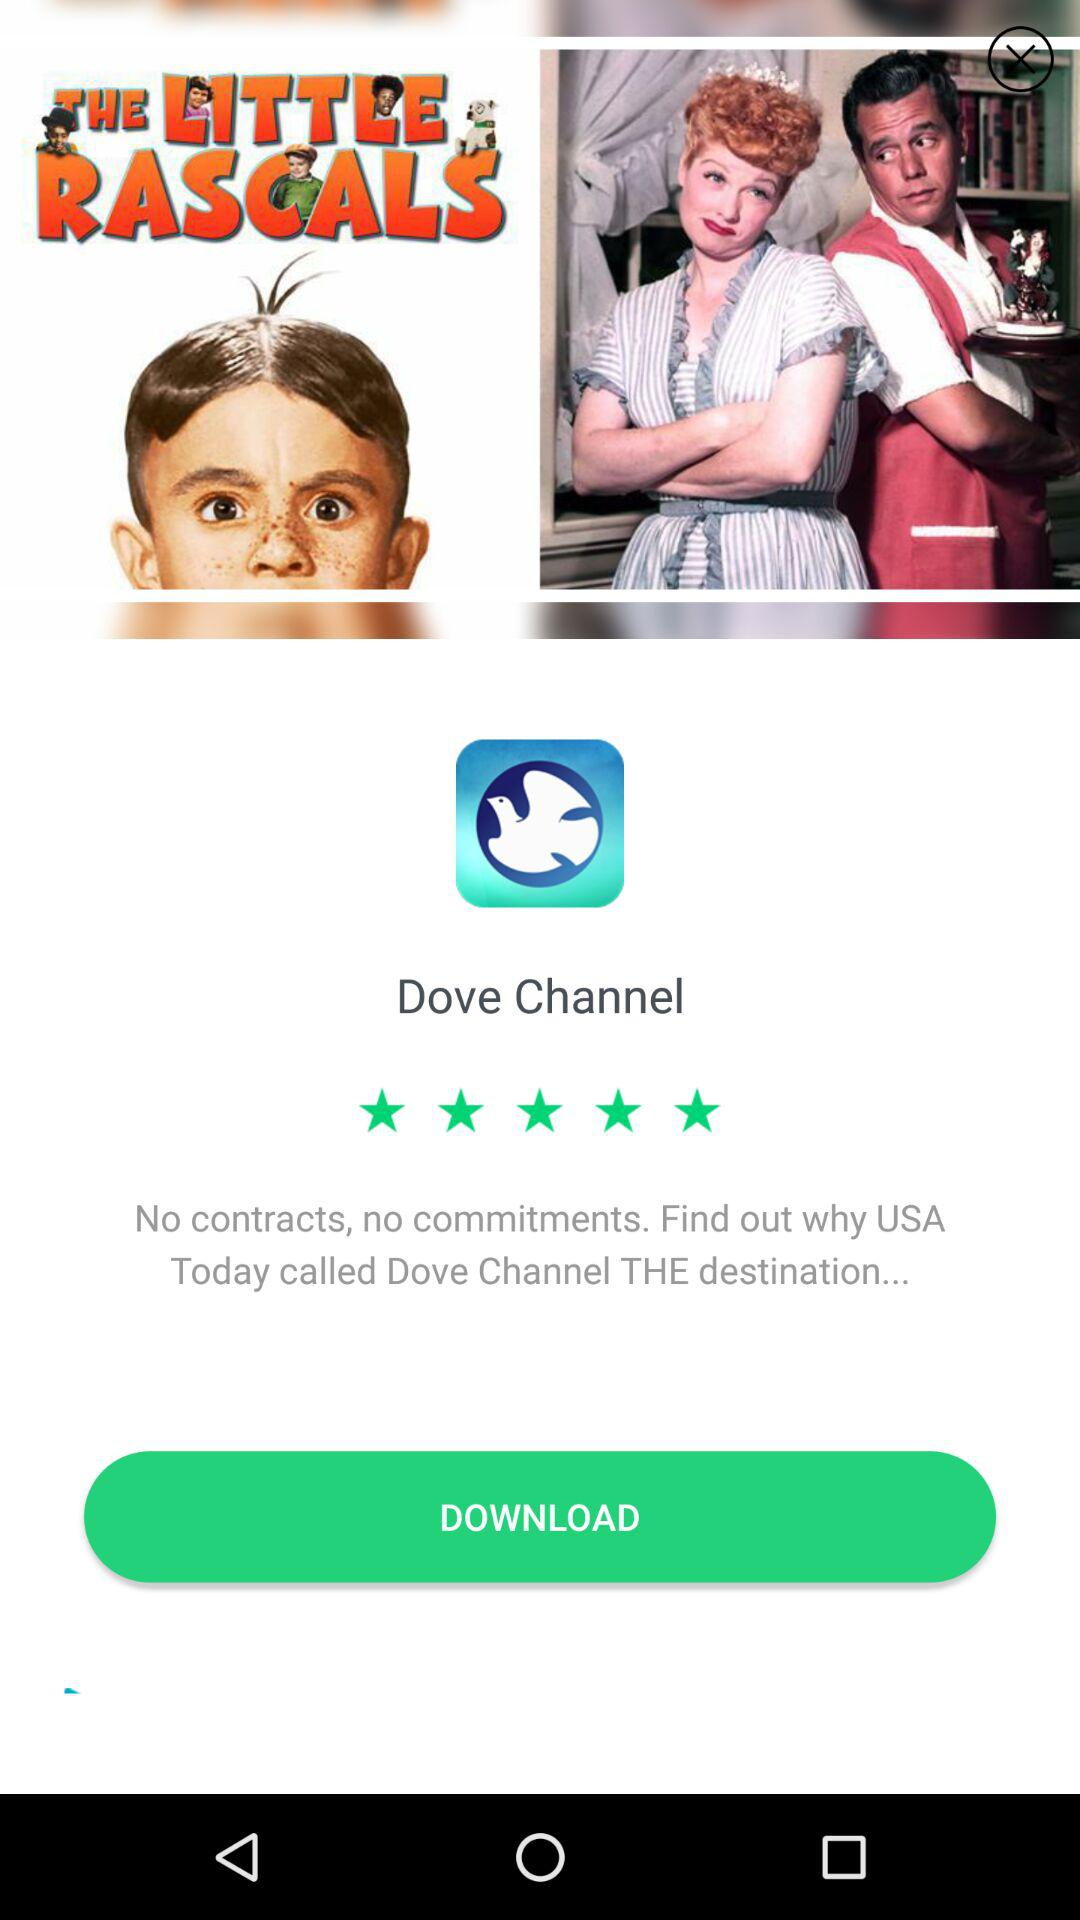What is the application name? The application name is "Dove Channel". 